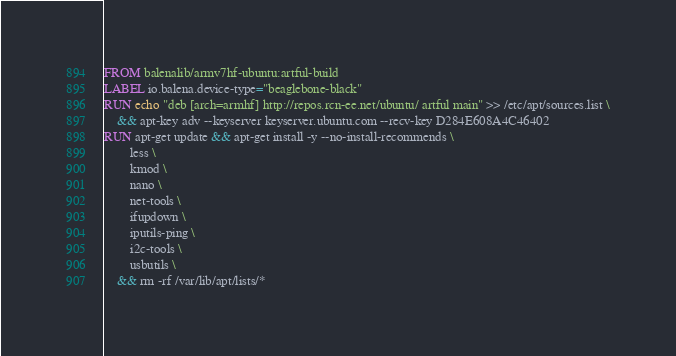<code> <loc_0><loc_0><loc_500><loc_500><_Dockerfile_>FROM balenalib/armv7hf-ubuntu:artful-build
LABEL io.balena.device-type="beaglebone-black"
RUN echo "deb [arch=armhf] http://repos.rcn-ee.net/ubuntu/ artful main" >> /etc/apt/sources.list \
	&& apt-key adv --keyserver keyserver.ubuntu.com --recv-key D284E608A4C46402
RUN apt-get update && apt-get install -y --no-install-recommends \
		less \
		kmod \
		nano \
		net-tools \
		ifupdown \
		iputils-ping \
		i2c-tools \
		usbutils \
	&& rm -rf /var/lib/apt/lists/*</code> 